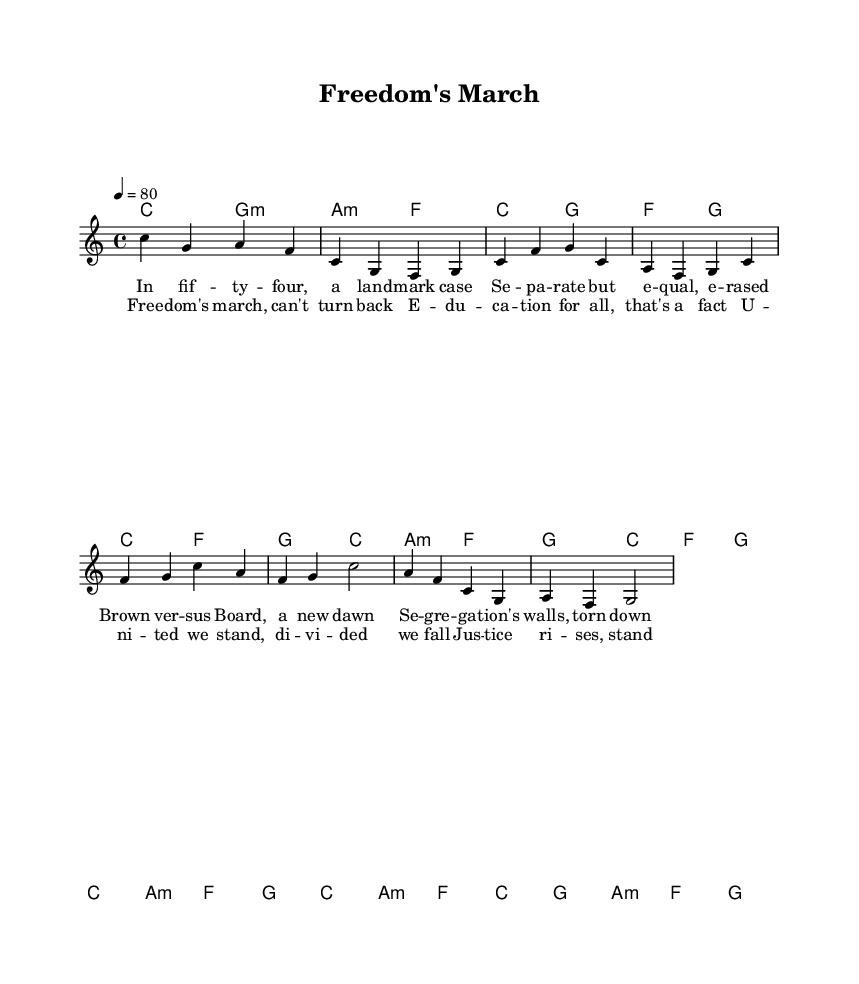What is the key signature of this music? The key signature is C major, which is indicated at the beginning of the score and shows no sharps or flats.
Answer: C major What is the time signature of this piece? The time signature is shown as 4/4 at the beginning of the score, meaning there are four beats in each measure and the quarter note gets one beat.
Answer: 4/4 What is the tempo marking for this score? The tempo marking is indicated as 4 = 80, which means there are 80 beats per minute for the quarter note, giving a moderate tempo for the song.
Answer: 80 How many measures are in the chorus section? By counting the number of measures in the chorus section, there are four distinct measures, as shown in the written music.
Answer: 4 What is the significance of the lyrics in the song? The lyrics address key civil rights milestones, specifically referencing the Brown v. Board of Education case of 1954, which is a significant legal case in American history for civil rights.
Answer: Brown v. Board of Education What kind of chord progression is prominent in this piece? The chord progression involves common reggae elements, including major and minor chords that provide a laid-back sound typical of reggae music.
Answer: Major and minor chords What is the overall theme of the song's lyrics? The overall theme focuses on civil rights, justice, and a collective movement toward equality and education for all, highlighting historical context.
Answer: Civil rights and justice 